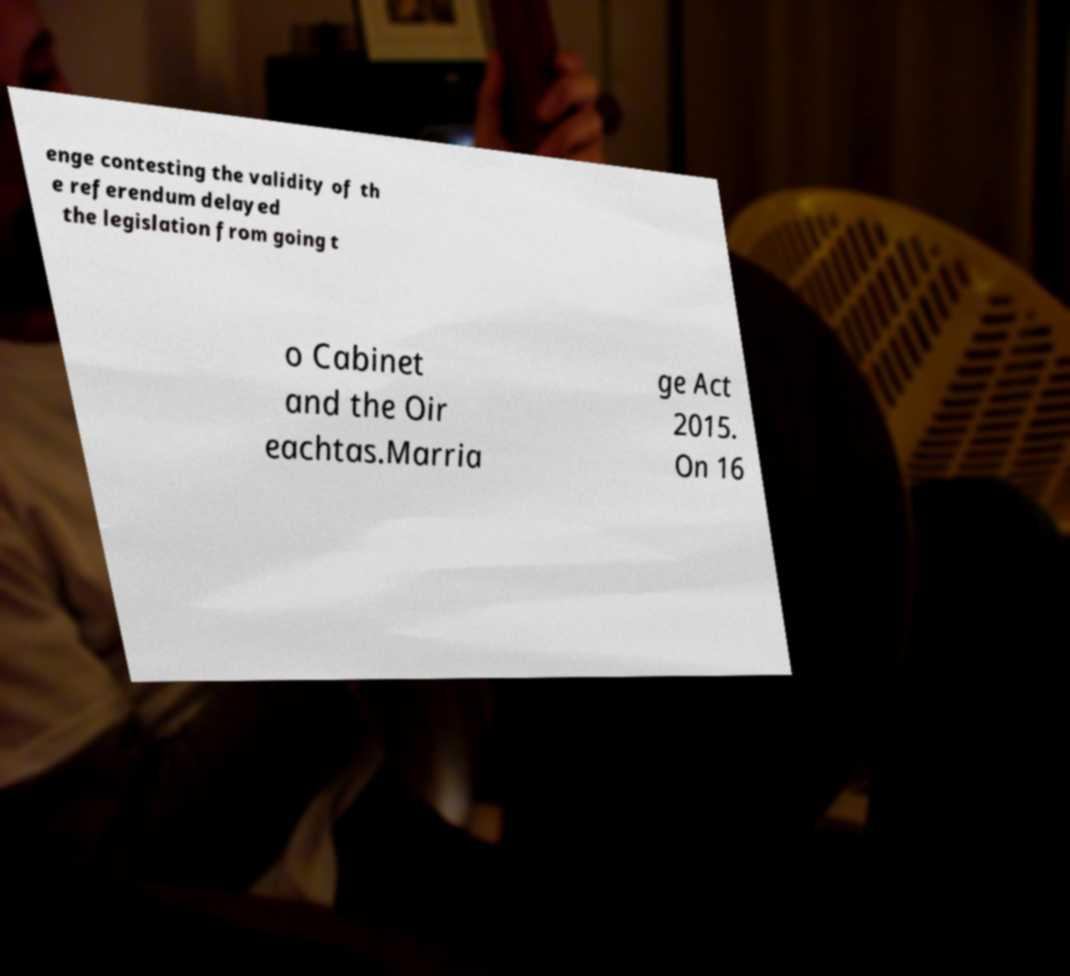I need the written content from this picture converted into text. Can you do that? enge contesting the validity of th e referendum delayed the legislation from going t o Cabinet and the Oir eachtas.Marria ge Act 2015. On 16 